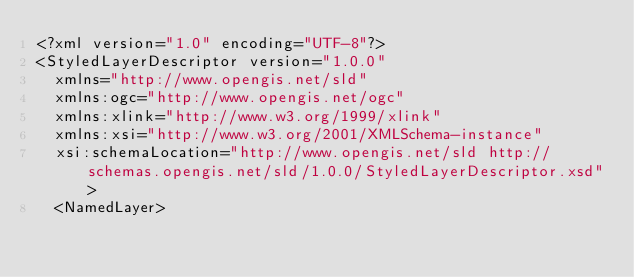<code> <loc_0><loc_0><loc_500><loc_500><_Scheme_><?xml version="1.0" encoding="UTF-8"?>
<StyledLayerDescriptor version="1.0.0"
  xmlns="http://www.opengis.net/sld"
  xmlns:ogc="http://www.opengis.net/ogc"
  xmlns:xlink="http://www.w3.org/1999/xlink"
  xmlns:xsi="http://www.w3.org/2001/XMLSchema-instance"
  xsi:schemaLocation="http://www.opengis.net/sld http://schemas.opengis.net/sld/1.0.0/StyledLayerDescriptor.xsd">
  <NamedLayer></code> 